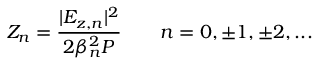<formula> <loc_0><loc_0><loc_500><loc_500>Z _ { n } = \frac { | E _ { z , n } | ^ { 2 } } { 2 \beta _ { n } ^ { 2 } P } \quad n = 0 , \pm 1 , \pm 2 , \dots</formula> 